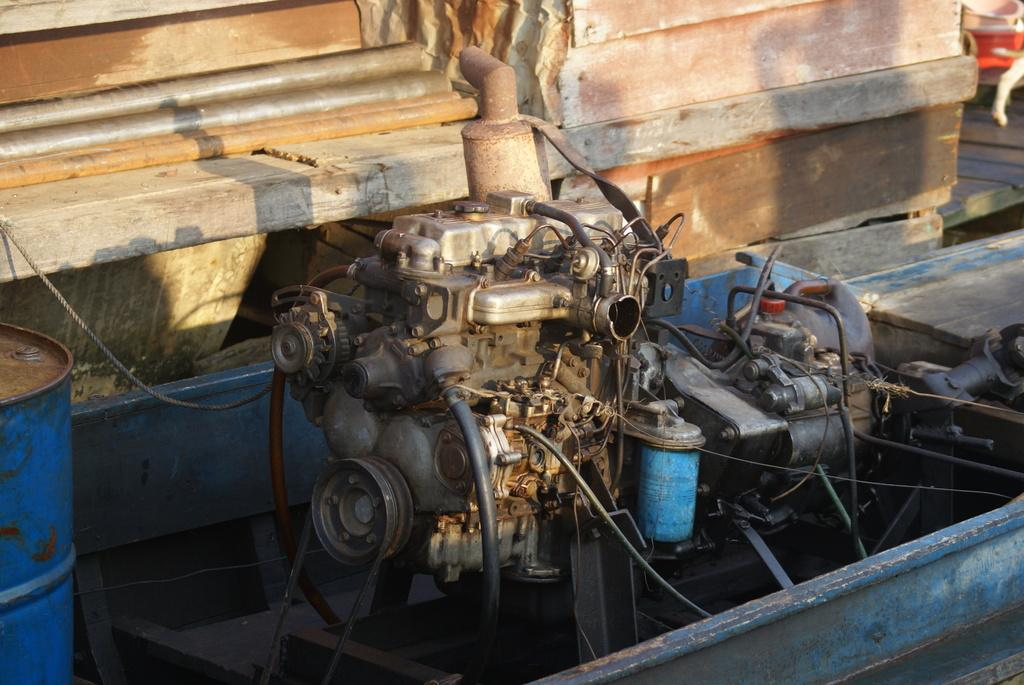What is the main object in the image? There is a machine in the image. Can you describe any specific features of the machine? To the left of the machine, there is a blue color drum. What is located to the right of the machine? There is a wooden table to the right of the machine. Can you tell me how many snails are crawling on the wooden table in the image? There are no snails present in the image; the wooden table is empty. What type of party is being held near the machine in the image? There is no party depicted in the image; it only features the machine, the blue color drum, and the wooden table. 